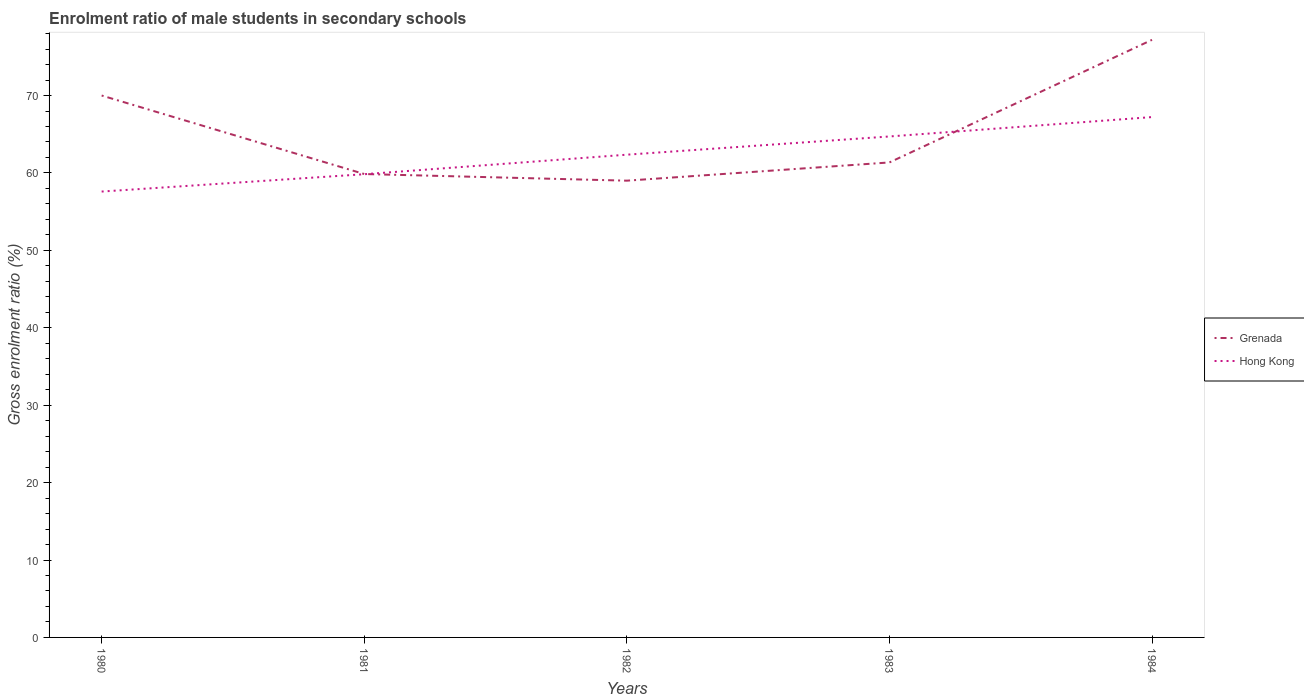How many different coloured lines are there?
Offer a very short reply. 2. Is the number of lines equal to the number of legend labels?
Your answer should be very brief. Yes. Across all years, what is the maximum enrolment ratio of male students in secondary schools in Grenada?
Your answer should be very brief. 59. In which year was the enrolment ratio of male students in secondary schools in Hong Kong maximum?
Provide a succinct answer. 1980. What is the total enrolment ratio of male students in secondary schools in Grenada in the graph?
Your response must be concise. 8.64. What is the difference between the highest and the second highest enrolment ratio of male students in secondary schools in Grenada?
Your answer should be very brief. 18.19. What is the difference between the highest and the lowest enrolment ratio of male students in secondary schools in Grenada?
Provide a short and direct response. 2. How many years are there in the graph?
Provide a short and direct response. 5. Are the values on the major ticks of Y-axis written in scientific E-notation?
Ensure brevity in your answer.  No. Does the graph contain any zero values?
Your answer should be very brief. No. Does the graph contain grids?
Provide a succinct answer. No. What is the title of the graph?
Make the answer very short. Enrolment ratio of male students in secondary schools. What is the Gross enrolment ratio (%) in Hong Kong in 1980?
Your answer should be compact. 57.6. What is the Gross enrolment ratio (%) of Grenada in 1981?
Provide a succinct answer. 59.86. What is the Gross enrolment ratio (%) of Hong Kong in 1981?
Offer a terse response. 59.83. What is the Gross enrolment ratio (%) of Grenada in 1982?
Your answer should be compact. 59. What is the Gross enrolment ratio (%) in Hong Kong in 1982?
Ensure brevity in your answer.  62.36. What is the Gross enrolment ratio (%) in Grenada in 1983?
Offer a very short reply. 61.36. What is the Gross enrolment ratio (%) in Hong Kong in 1983?
Offer a terse response. 64.71. What is the Gross enrolment ratio (%) in Grenada in 1984?
Make the answer very short. 77.19. What is the Gross enrolment ratio (%) in Hong Kong in 1984?
Your answer should be very brief. 67.22. Across all years, what is the maximum Gross enrolment ratio (%) in Grenada?
Give a very brief answer. 77.19. Across all years, what is the maximum Gross enrolment ratio (%) in Hong Kong?
Your answer should be compact. 67.22. Across all years, what is the minimum Gross enrolment ratio (%) in Grenada?
Offer a terse response. 59. Across all years, what is the minimum Gross enrolment ratio (%) in Hong Kong?
Ensure brevity in your answer.  57.6. What is the total Gross enrolment ratio (%) in Grenada in the graph?
Make the answer very short. 327.41. What is the total Gross enrolment ratio (%) in Hong Kong in the graph?
Make the answer very short. 311.71. What is the difference between the Gross enrolment ratio (%) in Grenada in 1980 and that in 1981?
Offer a terse response. 10.14. What is the difference between the Gross enrolment ratio (%) in Hong Kong in 1980 and that in 1981?
Ensure brevity in your answer.  -2.24. What is the difference between the Gross enrolment ratio (%) in Grenada in 1980 and that in 1982?
Your answer should be very brief. 11. What is the difference between the Gross enrolment ratio (%) in Hong Kong in 1980 and that in 1982?
Make the answer very short. -4.76. What is the difference between the Gross enrolment ratio (%) of Grenada in 1980 and that in 1983?
Provide a succinct answer. 8.64. What is the difference between the Gross enrolment ratio (%) in Hong Kong in 1980 and that in 1983?
Your answer should be compact. -7.12. What is the difference between the Gross enrolment ratio (%) of Grenada in 1980 and that in 1984?
Your answer should be compact. -7.19. What is the difference between the Gross enrolment ratio (%) in Hong Kong in 1980 and that in 1984?
Make the answer very short. -9.62. What is the difference between the Gross enrolment ratio (%) in Grenada in 1981 and that in 1982?
Provide a short and direct response. 0.86. What is the difference between the Gross enrolment ratio (%) in Hong Kong in 1981 and that in 1982?
Your response must be concise. -2.52. What is the difference between the Gross enrolment ratio (%) in Grenada in 1981 and that in 1983?
Keep it short and to the point. -1.5. What is the difference between the Gross enrolment ratio (%) in Hong Kong in 1981 and that in 1983?
Provide a succinct answer. -4.88. What is the difference between the Gross enrolment ratio (%) in Grenada in 1981 and that in 1984?
Provide a short and direct response. -17.33. What is the difference between the Gross enrolment ratio (%) in Hong Kong in 1981 and that in 1984?
Give a very brief answer. -7.38. What is the difference between the Gross enrolment ratio (%) in Grenada in 1982 and that in 1983?
Offer a very short reply. -2.35. What is the difference between the Gross enrolment ratio (%) in Hong Kong in 1982 and that in 1983?
Your answer should be very brief. -2.35. What is the difference between the Gross enrolment ratio (%) in Grenada in 1982 and that in 1984?
Provide a short and direct response. -18.19. What is the difference between the Gross enrolment ratio (%) in Hong Kong in 1982 and that in 1984?
Provide a succinct answer. -4.86. What is the difference between the Gross enrolment ratio (%) in Grenada in 1983 and that in 1984?
Provide a succinct answer. -15.84. What is the difference between the Gross enrolment ratio (%) in Hong Kong in 1983 and that in 1984?
Offer a terse response. -2.51. What is the difference between the Gross enrolment ratio (%) of Grenada in 1980 and the Gross enrolment ratio (%) of Hong Kong in 1981?
Make the answer very short. 10.17. What is the difference between the Gross enrolment ratio (%) in Grenada in 1980 and the Gross enrolment ratio (%) in Hong Kong in 1982?
Give a very brief answer. 7.64. What is the difference between the Gross enrolment ratio (%) of Grenada in 1980 and the Gross enrolment ratio (%) of Hong Kong in 1983?
Offer a very short reply. 5.29. What is the difference between the Gross enrolment ratio (%) in Grenada in 1980 and the Gross enrolment ratio (%) in Hong Kong in 1984?
Give a very brief answer. 2.78. What is the difference between the Gross enrolment ratio (%) in Grenada in 1981 and the Gross enrolment ratio (%) in Hong Kong in 1982?
Provide a succinct answer. -2.5. What is the difference between the Gross enrolment ratio (%) in Grenada in 1981 and the Gross enrolment ratio (%) in Hong Kong in 1983?
Make the answer very short. -4.85. What is the difference between the Gross enrolment ratio (%) in Grenada in 1981 and the Gross enrolment ratio (%) in Hong Kong in 1984?
Make the answer very short. -7.36. What is the difference between the Gross enrolment ratio (%) of Grenada in 1982 and the Gross enrolment ratio (%) of Hong Kong in 1983?
Your answer should be compact. -5.71. What is the difference between the Gross enrolment ratio (%) of Grenada in 1982 and the Gross enrolment ratio (%) of Hong Kong in 1984?
Provide a succinct answer. -8.21. What is the difference between the Gross enrolment ratio (%) in Grenada in 1983 and the Gross enrolment ratio (%) in Hong Kong in 1984?
Provide a short and direct response. -5.86. What is the average Gross enrolment ratio (%) of Grenada per year?
Offer a terse response. 65.48. What is the average Gross enrolment ratio (%) in Hong Kong per year?
Ensure brevity in your answer.  62.34. In the year 1980, what is the difference between the Gross enrolment ratio (%) of Grenada and Gross enrolment ratio (%) of Hong Kong?
Offer a very short reply. 12.4. In the year 1981, what is the difference between the Gross enrolment ratio (%) in Grenada and Gross enrolment ratio (%) in Hong Kong?
Give a very brief answer. 0.02. In the year 1982, what is the difference between the Gross enrolment ratio (%) in Grenada and Gross enrolment ratio (%) in Hong Kong?
Offer a terse response. -3.36. In the year 1983, what is the difference between the Gross enrolment ratio (%) of Grenada and Gross enrolment ratio (%) of Hong Kong?
Offer a very short reply. -3.35. In the year 1984, what is the difference between the Gross enrolment ratio (%) in Grenada and Gross enrolment ratio (%) in Hong Kong?
Offer a terse response. 9.98. What is the ratio of the Gross enrolment ratio (%) of Grenada in 1980 to that in 1981?
Ensure brevity in your answer.  1.17. What is the ratio of the Gross enrolment ratio (%) in Hong Kong in 1980 to that in 1981?
Your answer should be very brief. 0.96. What is the ratio of the Gross enrolment ratio (%) of Grenada in 1980 to that in 1982?
Offer a very short reply. 1.19. What is the ratio of the Gross enrolment ratio (%) in Hong Kong in 1980 to that in 1982?
Your answer should be compact. 0.92. What is the ratio of the Gross enrolment ratio (%) in Grenada in 1980 to that in 1983?
Offer a very short reply. 1.14. What is the ratio of the Gross enrolment ratio (%) in Hong Kong in 1980 to that in 1983?
Offer a very short reply. 0.89. What is the ratio of the Gross enrolment ratio (%) in Grenada in 1980 to that in 1984?
Keep it short and to the point. 0.91. What is the ratio of the Gross enrolment ratio (%) of Hong Kong in 1980 to that in 1984?
Make the answer very short. 0.86. What is the ratio of the Gross enrolment ratio (%) of Grenada in 1981 to that in 1982?
Give a very brief answer. 1.01. What is the ratio of the Gross enrolment ratio (%) of Hong Kong in 1981 to that in 1982?
Your answer should be compact. 0.96. What is the ratio of the Gross enrolment ratio (%) in Grenada in 1981 to that in 1983?
Your answer should be very brief. 0.98. What is the ratio of the Gross enrolment ratio (%) of Hong Kong in 1981 to that in 1983?
Provide a short and direct response. 0.92. What is the ratio of the Gross enrolment ratio (%) in Grenada in 1981 to that in 1984?
Provide a succinct answer. 0.78. What is the ratio of the Gross enrolment ratio (%) of Hong Kong in 1981 to that in 1984?
Offer a terse response. 0.89. What is the ratio of the Gross enrolment ratio (%) of Grenada in 1982 to that in 1983?
Keep it short and to the point. 0.96. What is the ratio of the Gross enrolment ratio (%) in Hong Kong in 1982 to that in 1983?
Your answer should be very brief. 0.96. What is the ratio of the Gross enrolment ratio (%) in Grenada in 1982 to that in 1984?
Keep it short and to the point. 0.76. What is the ratio of the Gross enrolment ratio (%) of Hong Kong in 1982 to that in 1984?
Make the answer very short. 0.93. What is the ratio of the Gross enrolment ratio (%) in Grenada in 1983 to that in 1984?
Keep it short and to the point. 0.79. What is the ratio of the Gross enrolment ratio (%) of Hong Kong in 1983 to that in 1984?
Ensure brevity in your answer.  0.96. What is the difference between the highest and the second highest Gross enrolment ratio (%) in Grenada?
Offer a very short reply. 7.19. What is the difference between the highest and the second highest Gross enrolment ratio (%) in Hong Kong?
Offer a very short reply. 2.51. What is the difference between the highest and the lowest Gross enrolment ratio (%) in Grenada?
Make the answer very short. 18.19. What is the difference between the highest and the lowest Gross enrolment ratio (%) in Hong Kong?
Make the answer very short. 9.62. 